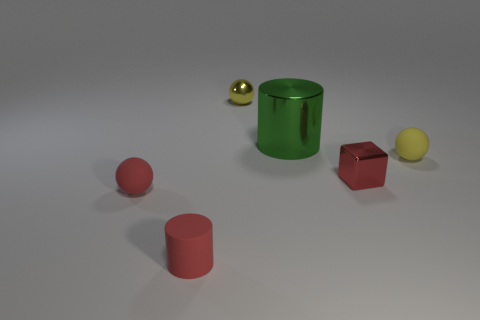Are there any tiny red things right of the red rubber ball?
Your answer should be compact. Yes. Is the number of rubber cylinders on the right side of the yellow matte ball less than the number of tiny metal objects?
Your response must be concise. Yes. What is the material of the green object?
Offer a terse response. Metal. The small metallic cube has what color?
Provide a succinct answer. Red. The matte object that is both in front of the red shiny cube and to the right of the tiny red matte sphere is what color?
Keep it short and to the point. Red. Are the red block and the ball to the left of the tiny red cylinder made of the same material?
Offer a very short reply. No. There is a yellow sphere on the left side of the yellow thing in front of the green metallic object; what size is it?
Offer a terse response. Small. Is there anything else that is the same color as the tiny matte cylinder?
Offer a very short reply. Yes. Are the yellow ball behind the large cylinder and the red object left of the red cylinder made of the same material?
Offer a very short reply. No. What is the material of the small ball that is both left of the metallic cylinder and in front of the green cylinder?
Offer a terse response. Rubber. 